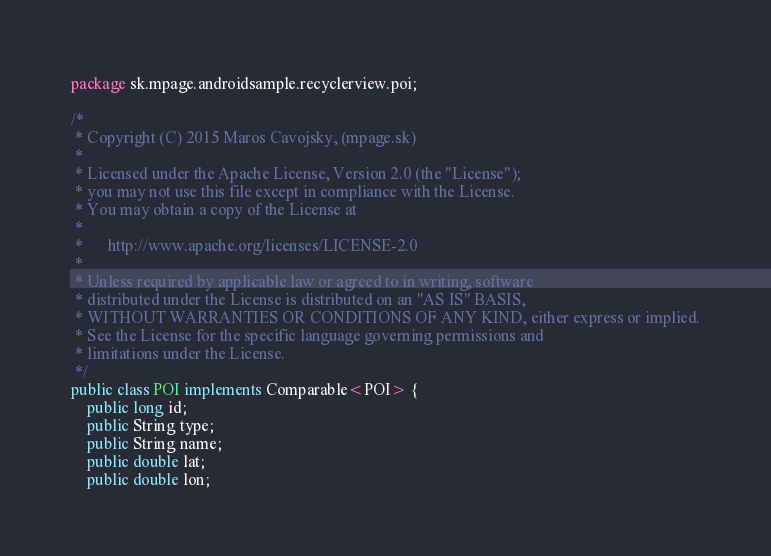<code> <loc_0><loc_0><loc_500><loc_500><_Java_>package sk.mpage.androidsample.recyclerview.poi;

/*
 * Copyright (C) 2015 Maros Cavojsky, (mpage.sk)
 *
 * Licensed under the Apache License, Version 2.0 (the "License");
 * you may not use this file except in compliance with the License.
 * You may obtain a copy of the License at
 *
 *      http://www.apache.org/licenses/LICENSE-2.0
 *
 * Unless required by applicable law or agreed to in writing, software
 * distributed under the License is distributed on an "AS IS" BASIS,
 * WITHOUT WARRANTIES OR CONDITIONS OF ANY KIND, either express or implied.
 * See the License for the specific language governing permissions and
 * limitations under the License.
 */
public class POI implements Comparable<POI> {
    public long id;
    public String type;
    public String name;
    public double lat;
    public double lon;</code> 